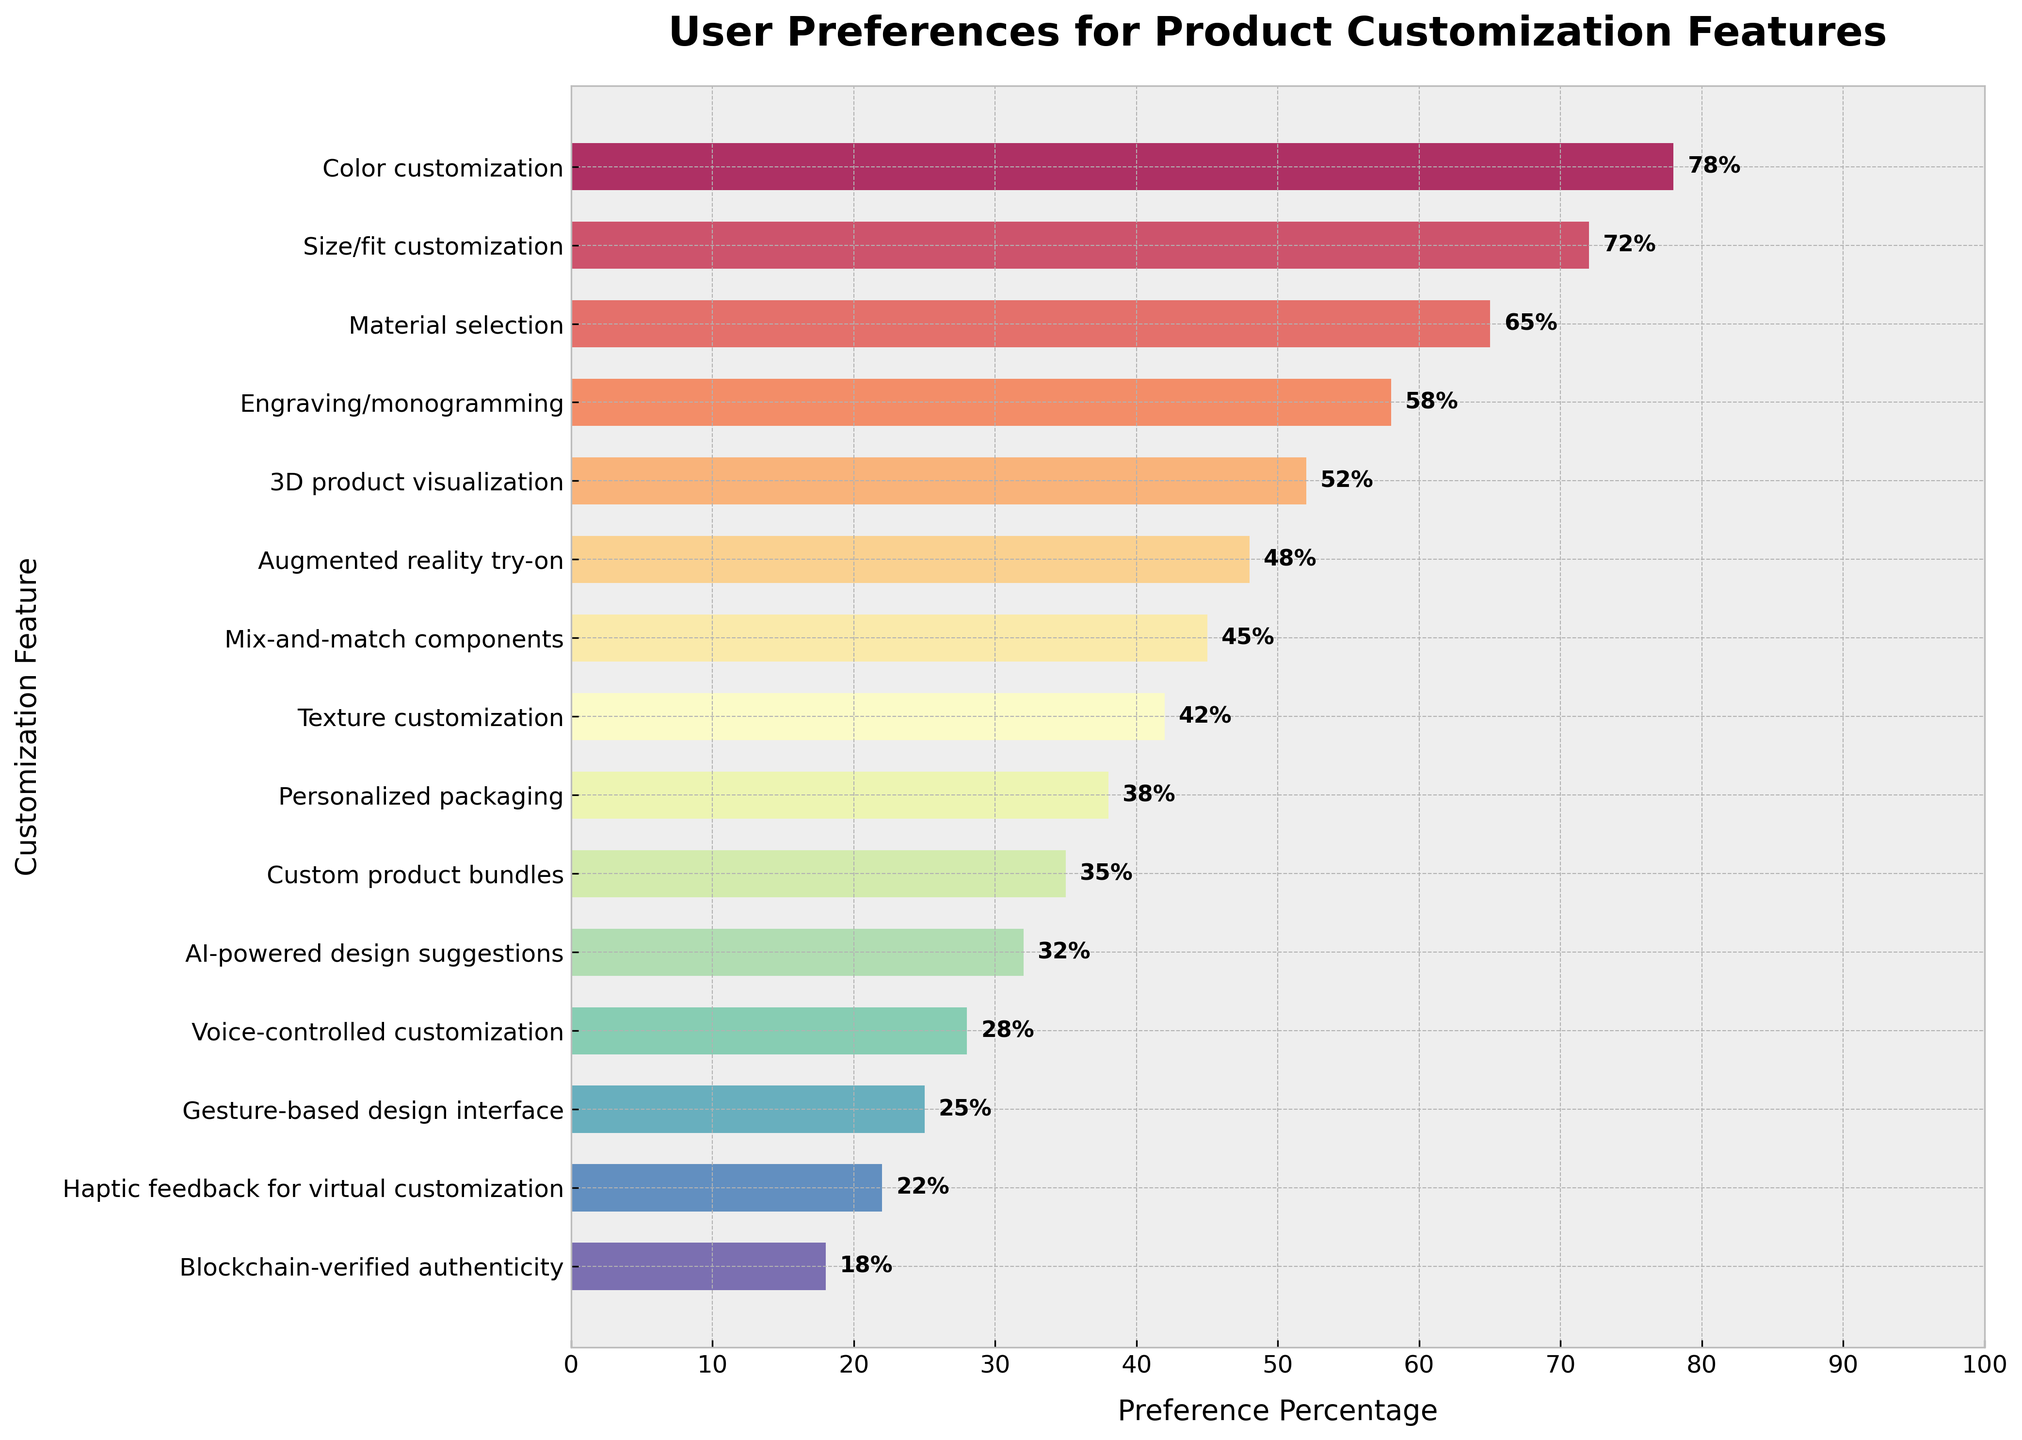Which customization feature has the highest user preference percentage? The bar for "Color customization" is the longest in the chart, indicating the highest percentage of 78%.
Answer: Color customization Which customization feature has the lowest user preference percentage? The bar for "Blockchain-verified authenticity" is the shortest in the chart, indicating the lowest percentage of 18%.
Answer: Blockchain-verified authenticity How much higher is the preference for "3D product visualization" compared to "AI-powered design suggestions"? The preference for "3D product visualization" is 52%, and for "AI-powered design suggestions" is 32%. The difference is 52% - 32% = 20%.
Answer: 20% What is the average preference percentage for the top three customization features? The top three features are "Color customization" (78%), "Size/fit customization" (72%), and "Material selection" (65%). The average is (78% + 72% + 65%) / 3 = 71.67%.
Answer: 71.67% Which feature has a user preference percentage closer to the mid-point of the chart (50%)? "3D product visualization" has a user preference of 52%, which is the closest to the midpoint of 50%.
Answer: 3D product visualization What percentage difference exists between "Engraving/monogramming" and "Mix-and-match components"? The preference for "Engraving/monogramming" is 58%, and for "Mix-and-match components" is 45%. The difference is 58% - 45% = 13%.
Answer: 13% Which customization feature has a user preference percentage twice as high as "Voice-controlled customization"? "Voice-controlled customization" has a preference of 28%. Twice this percentage is 2 * 28% = 56%. The closest feature is "Engraving/monogramming" at 58%.
Answer: Engraving/monogramming How many customization features have a preference percentage above 50%? The features with percentages above 50% are "Color customization", "Size/fit customization", "Material selection", "Engraving/monogramming", and "3D product visualization". A total of 5 features.
Answer: 5 Which feature ranks fifth in user preference? The fifth feature in descending order is "3D product visualization" with a preference of 52%.
Answer: 3D product visualization 